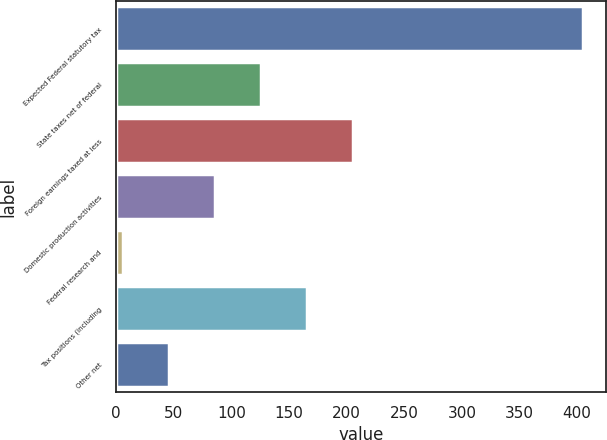<chart> <loc_0><loc_0><loc_500><loc_500><bar_chart><fcel>Expected Federal statutory tax<fcel>State taxes net of federal<fcel>Foreign earnings taxed at less<fcel>Domestic production activities<fcel>Federal research and<fcel>Tax positions (including<fcel>Other net<nl><fcel>405<fcel>125.7<fcel>205.5<fcel>85.8<fcel>6<fcel>165.6<fcel>45.9<nl></chart> 